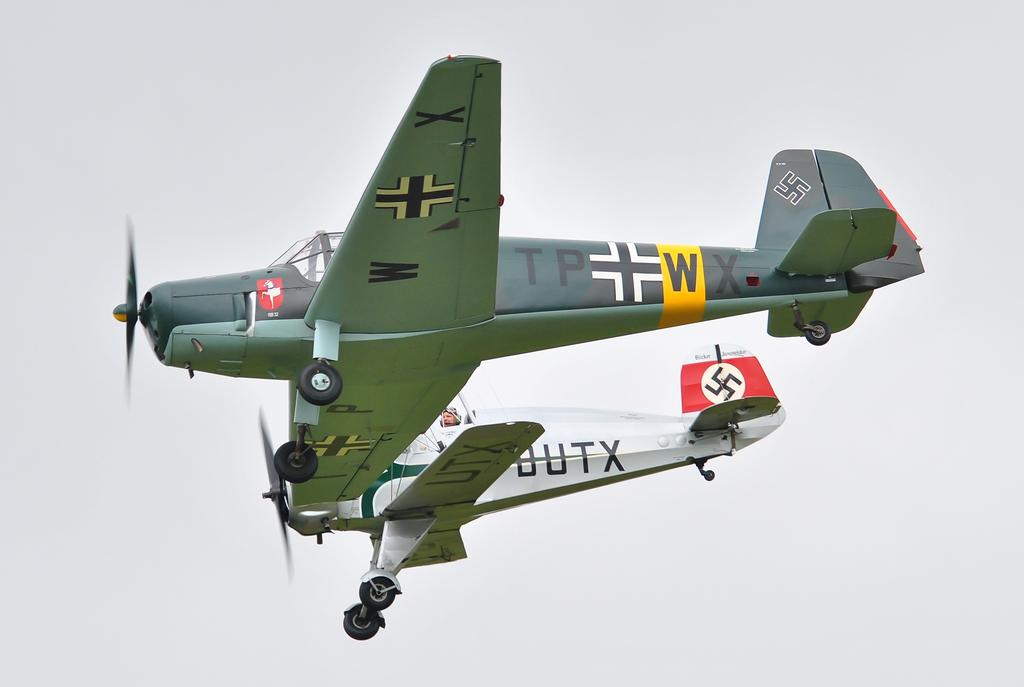What is written on the body of the white plane?
Ensure brevity in your answer.  Dutx. What two letters are on the middle of the green plane?
Give a very brief answer. Tp. 